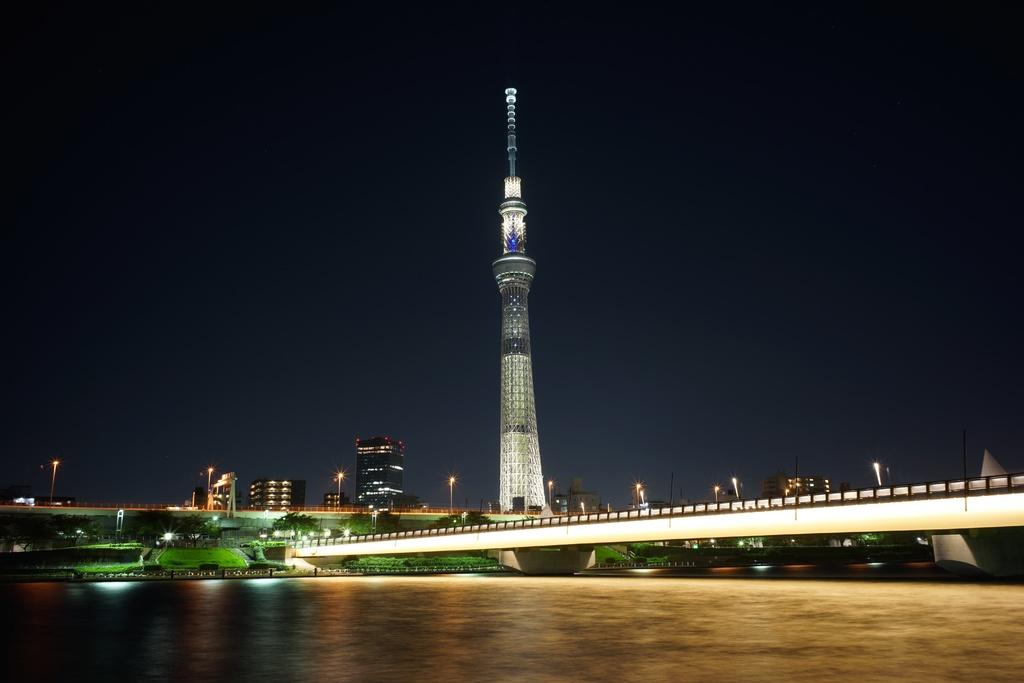How many bridges can be seen in the image? There are two bridges in the image. What other structures are present in the image besides the bridges? There is a tower, poles, lights, trees, grass, buildings, and water visible in the image. What type of vegetation is present in the image? There are trees and grass in the image. What might be used to illuminate the area in the image? There are lights in the image that could be used for illumination. What type of thread is being used to hold up the potato in the image? There is no potato or thread present in the image. What is the weather like in the image? The provided facts do not mention the weather, so it cannot be determined from the image. 